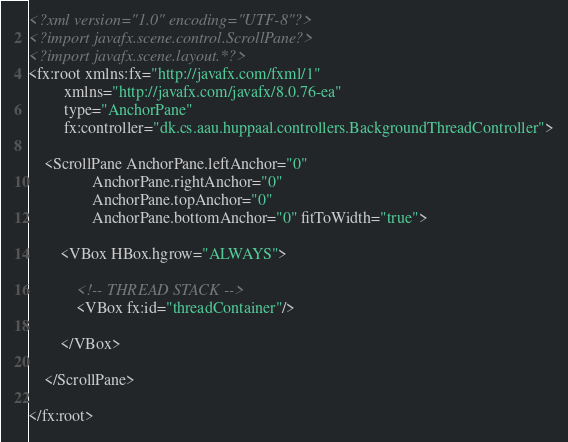<code> <loc_0><loc_0><loc_500><loc_500><_XML_><?xml version="1.0" encoding="UTF-8"?>
<?import javafx.scene.control.ScrollPane?>
<?import javafx.scene.layout.*?>
<fx:root xmlns:fx="http://javafx.com/fxml/1"
         xmlns="http://javafx.com/javafx/8.0.76-ea"
         type="AnchorPane"
         fx:controller="dk.cs.aau.huppaal.controllers.BackgroundThreadController">

    <ScrollPane AnchorPane.leftAnchor="0"
                AnchorPane.rightAnchor="0"
                AnchorPane.topAnchor="0"
                AnchorPane.bottomAnchor="0" fitToWidth="true">

        <VBox HBox.hgrow="ALWAYS">

            <!-- THREAD STACK -->
            <VBox fx:id="threadContainer"/>

        </VBox>

    </ScrollPane>

</fx:root></code> 